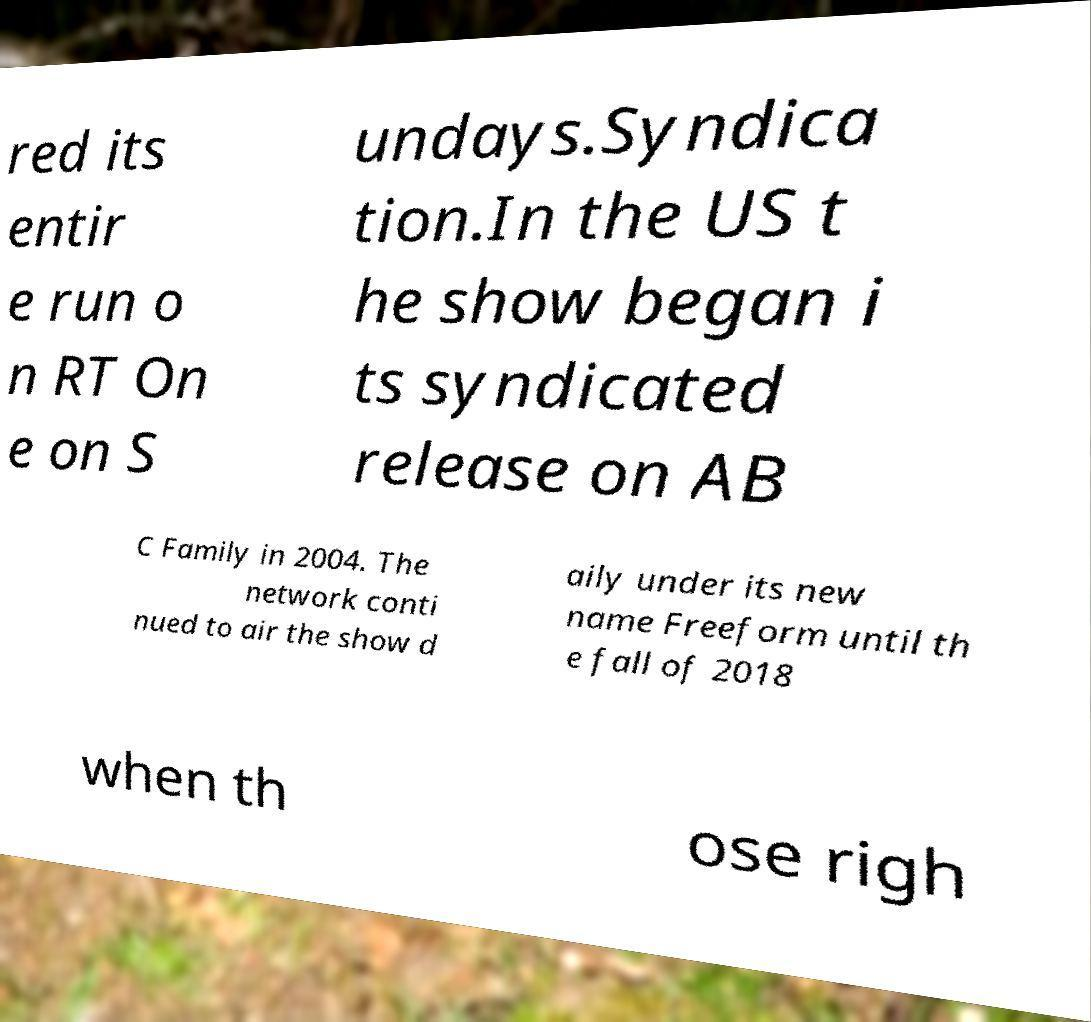Can you accurately transcribe the text from the provided image for me? red its entir e run o n RT On e on S undays.Syndica tion.In the US t he show began i ts syndicated release on AB C Family in 2004. The network conti nued to air the show d aily under its new name Freeform until th e fall of 2018 when th ose righ 